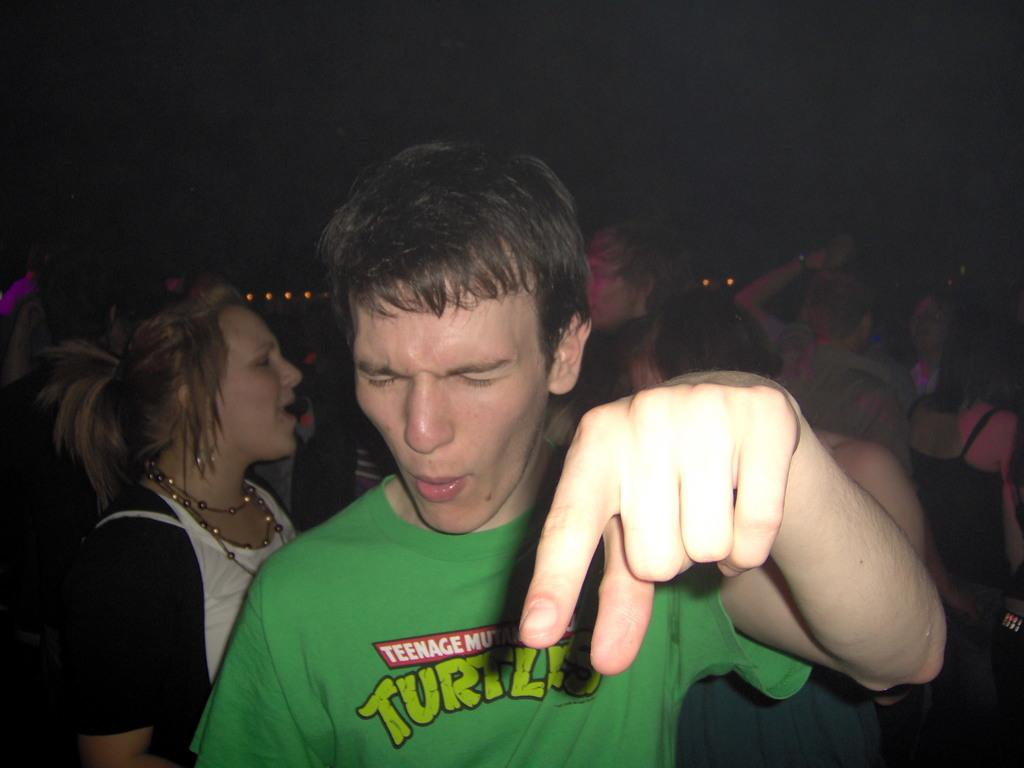How many people are in the image? There is a group of people in the image, but the exact number is not specified. What can be seen in the background of the image? The background of the image is dark. What flavor of drink is being held by the person in the image? There is no information about a drink or its flavor in the image. Can you describe the picture hanging on the wall in the image? There is no mention of a picture hanging on the wall in the image. 